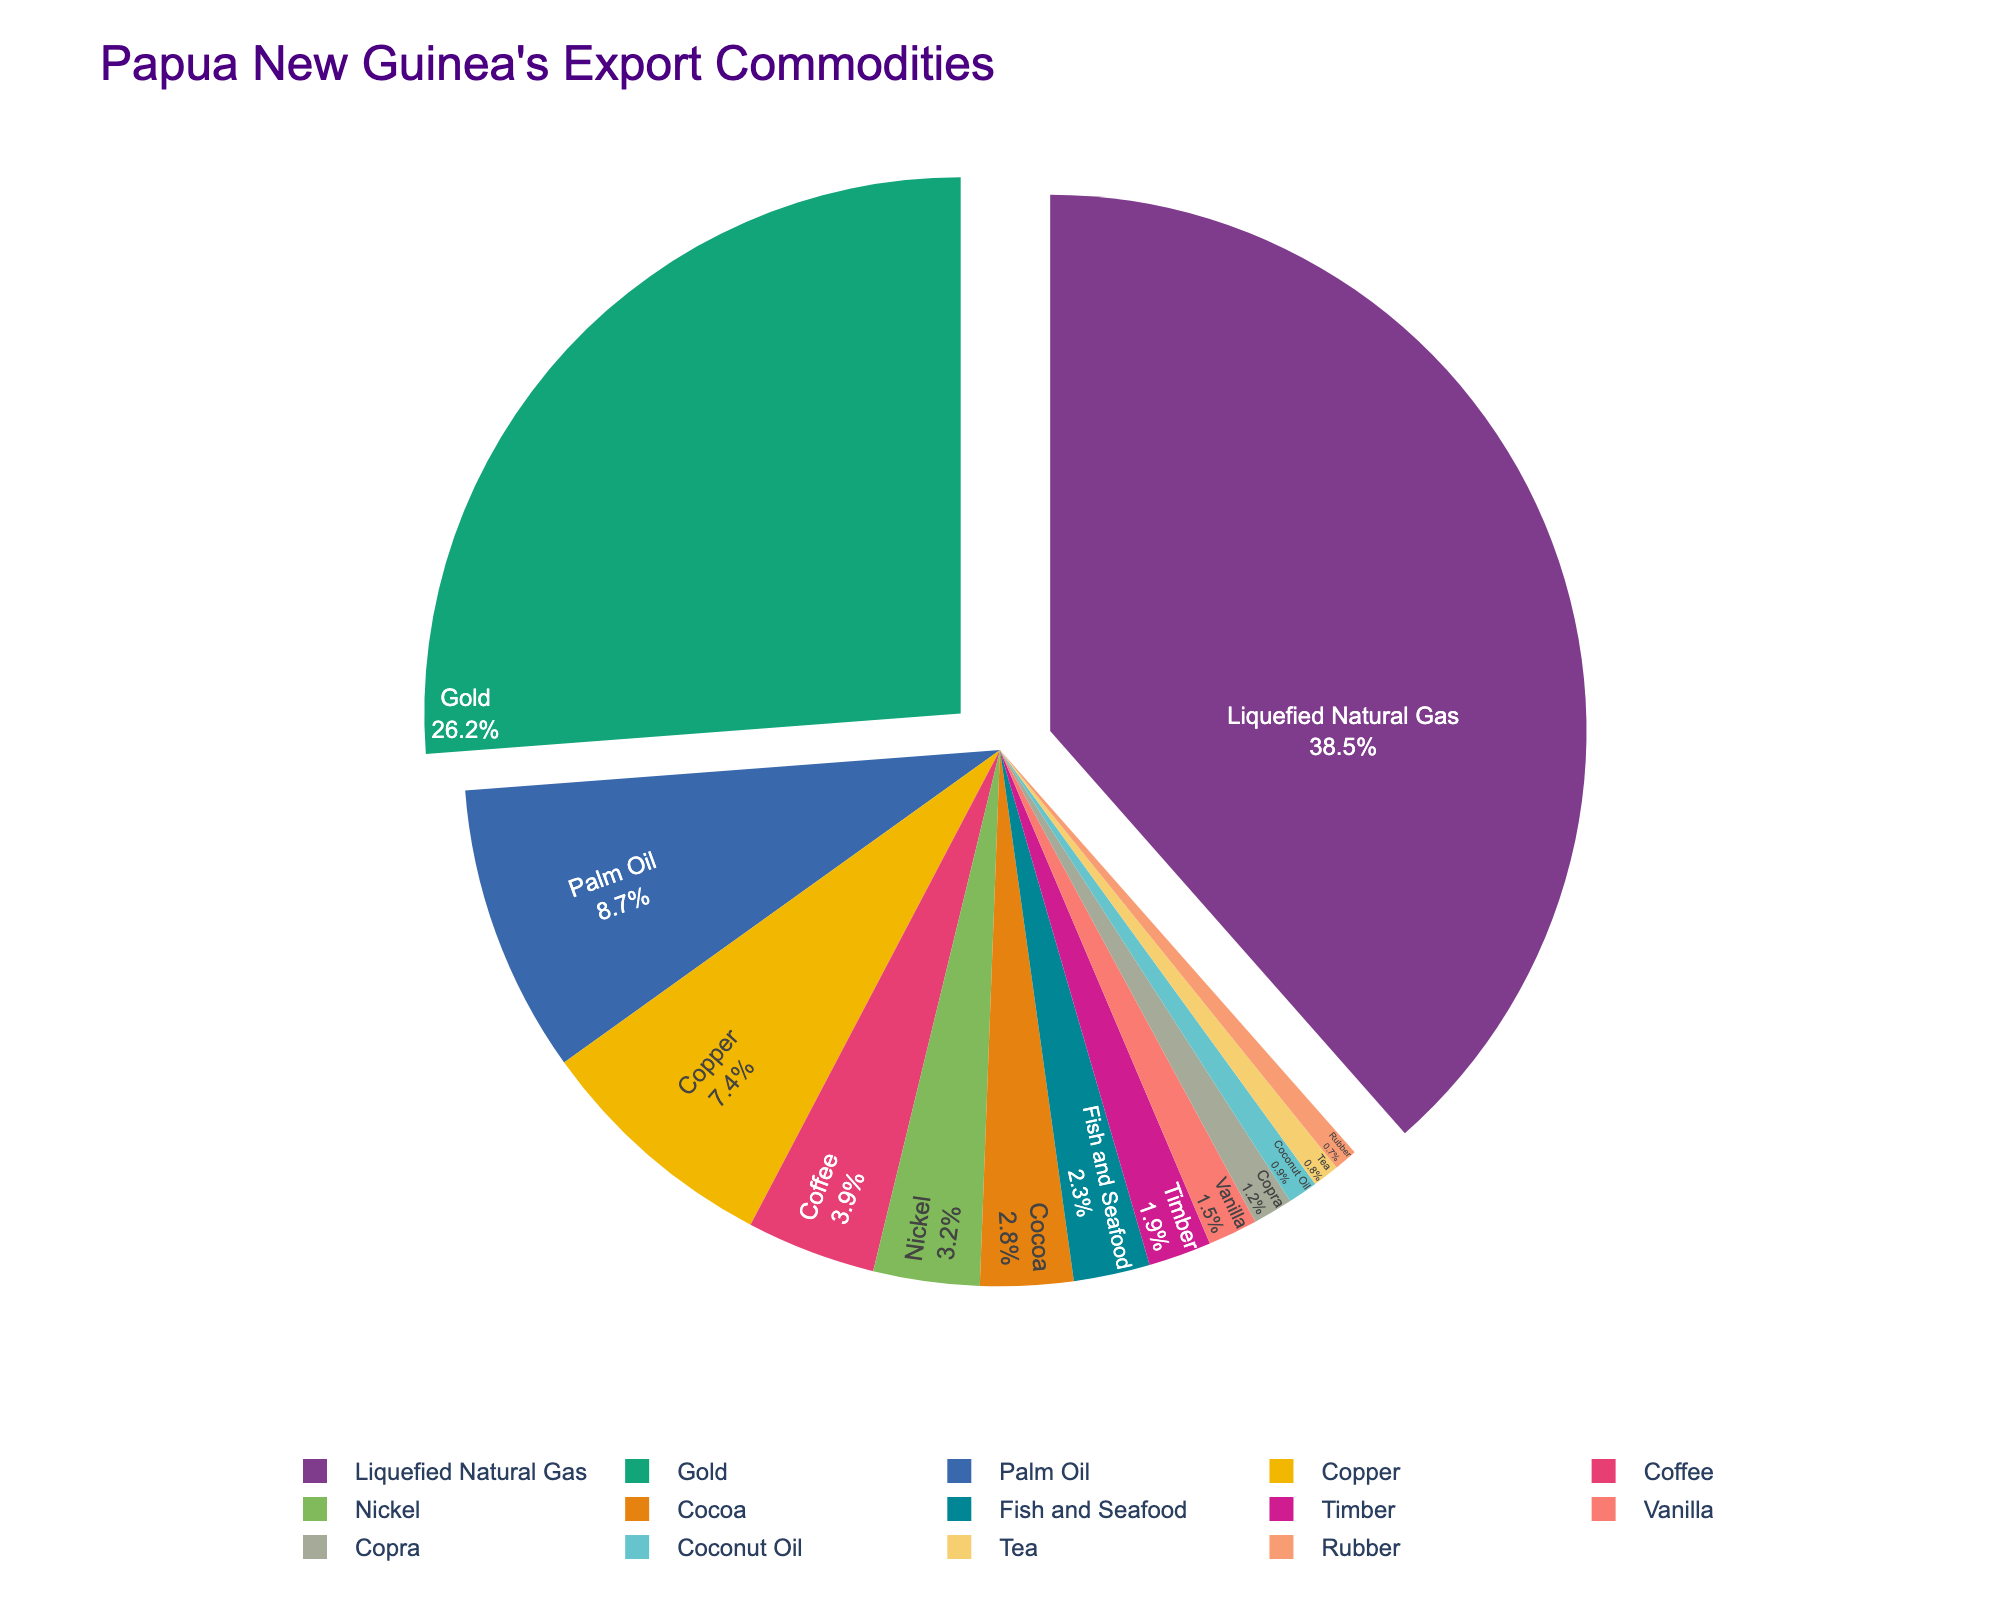What's the percentage of the top two export commodities combined? The top two export commodities are Liquefied Natural Gas (38.5%) and Gold (26.2%). Their combined percentage is 38.5% + 26.2% = 64.7%.
Answer: 64.7% Which export commodity has a percentage closest to 10%? By scanning the percentages, Palm Oil has a value of 8.7%, which is closest to 10%.
Answer: Palm Oil How does the percentage of Copper compare to Nickel? Copper has a percentage of 7.4%, and Nickel has 3.2%. So, Copper's percentage is greater than Nickel's.
Answer: Greater What's the difference in percentage between Coffee and Cocoa? Coffee has a percentage of 3.9%, and Cocoa has 2.8%. The difference is 3.9% - 2.8% = 1.1%.
Answer: 1.1% What is the sum percentage of the commodities that make up less than 3% each? The commodities under 3% are Nickel (3.2%), Cocoa (2.8%), Fish and Seafood (2.3%), Timber (1.9%), Vanilla (1.5%), Copra (1.2%), Coconut Oil (0.9%), Tea (0.8%), Rubber (0.7%). Summing their percentages: 3.2 + 2.8 + 2.3 + 1.9 + 1.5 + 1.2 + 0.9 + 0.8 + 0.7 = 15.3%.
Answer: 15.3% Which export commodity occupies the least amount of the pie chart? By observing the percentages, Rubber has the smallest value at 0.7%.
Answer: Rubber Is the percentage of Palm Oil greater than the combined percentage of Timber and Vanilla? Palm Oil has 8.7%. Timber and Vanilla combined is 1.9% + 1.5% = 3.4%. Therefore, 8.7% is greater than 3.4%.
Answer: Yes What's the total percentage of the commodities not shown in the top three (LNG, Gold, Palm Oil)? The combined percentage of the top three commodities is 38.5 + 26.2 + 8.7 = 73.4%. Therefore, the remaining percentage is 100% - 73.4% = 26.6%.
Answer: 26.6% How much more percentage does Liquefied Natural Gas have compared to Nickel? Liquefied Natural Gas has 38.5%, and Nickel has 3.2%. The difference is 38.5% - 3.2% = 35.3%.
Answer: 35.3% 